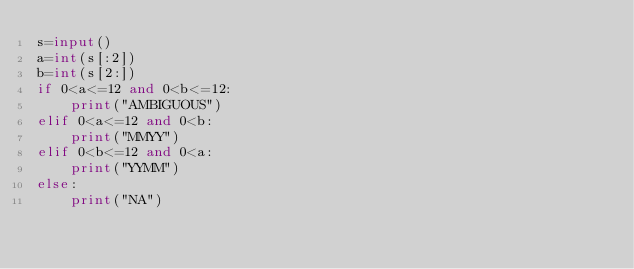Convert code to text. <code><loc_0><loc_0><loc_500><loc_500><_Python_>s=input()
a=int(s[:2])
b=int(s[2:])
if 0<a<=12 and 0<b<=12:
    print("AMBIGUOUS")
elif 0<a<=12 and 0<b:
    print("MMYY")
elif 0<b<=12 and 0<a:
    print("YYMM")
else:
    print("NA")
</code> 